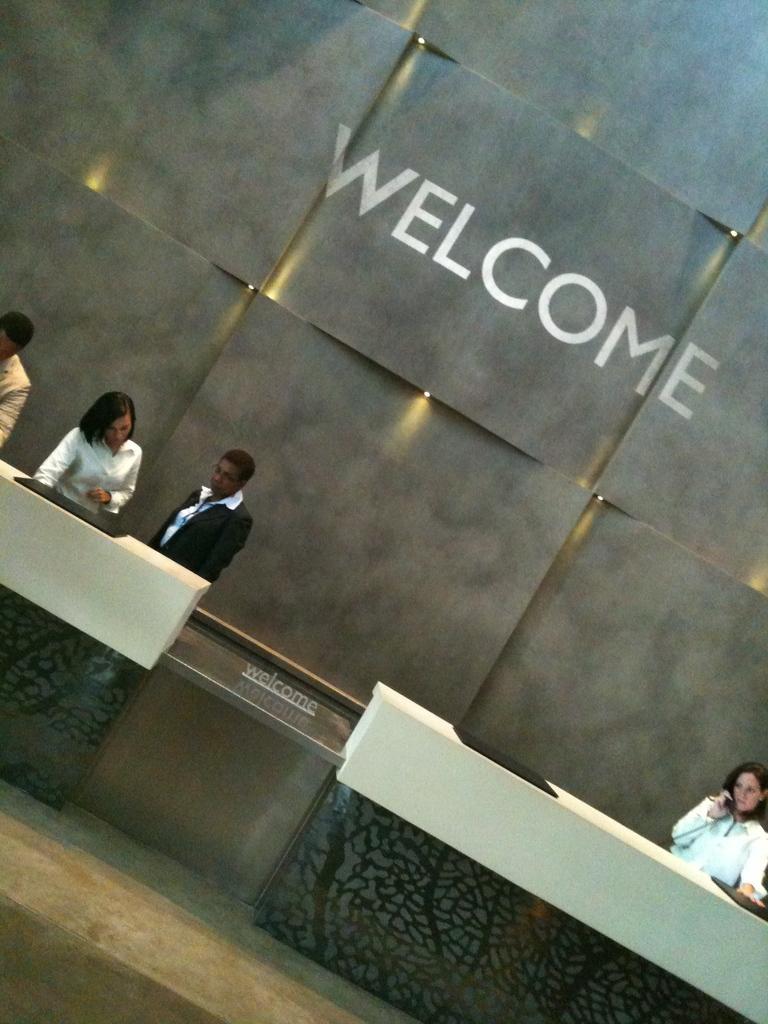Please provide a concise description of this image. In this image we can see some people standing, and a person on the right side holding a telephone and in the background I can see a text written on the wall. 